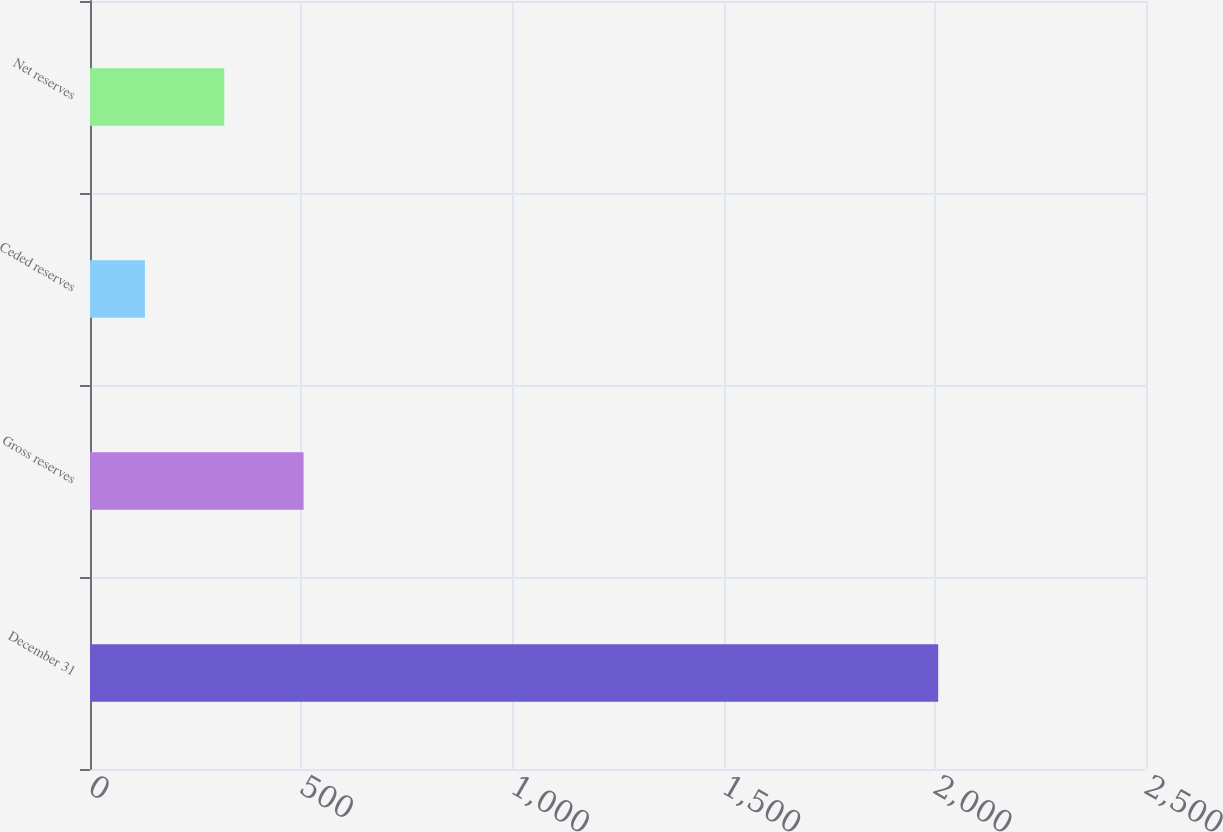Convert chart. <chart><loc_0><loc_0><loc_500><loc_500><bar_chart><fcel>December 31<fcel>Gross reserves<fcel>Ceded reserves<fcel>Net reserves<nl><fcel>2008<fcel>505.6<fcel>130<fcel>317.8<nl></chart> 